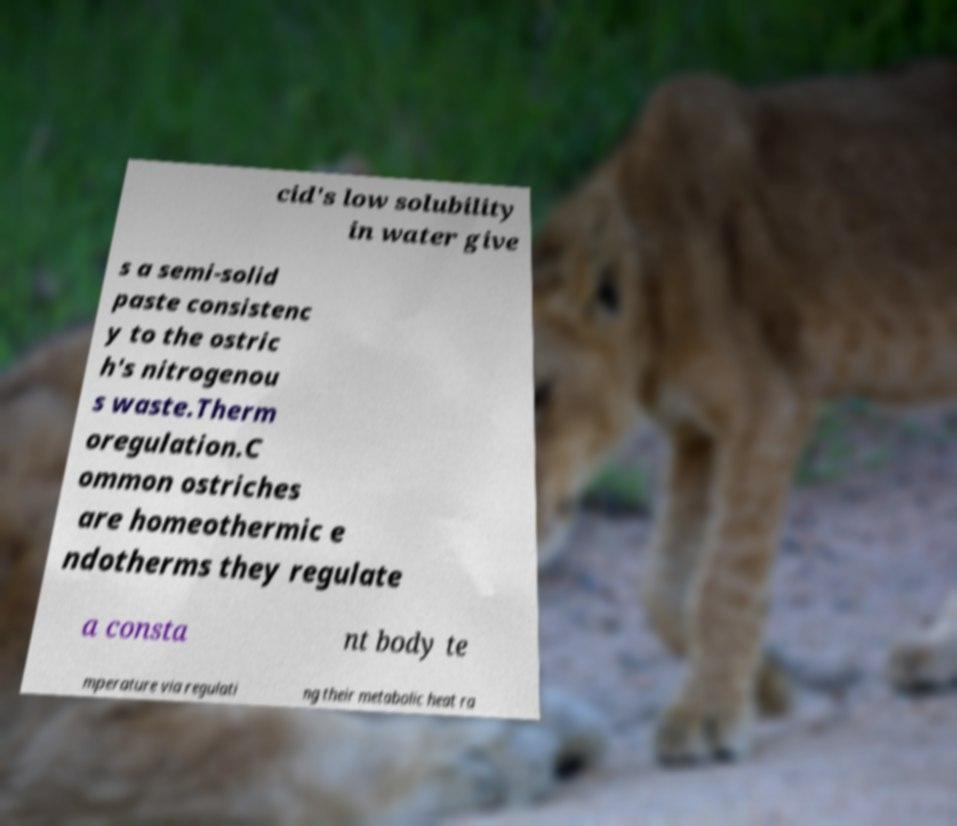There's text embedded in this image that I need extracted. Can you transcribe it verbatim? cid's low solubility in water give s a semi-solid paste consistenc y to the ostric h's nitrogenou s waste.Therm oregulation.C ommon ostriches are homeothermic e ndotherms they regulate a consta nt body te mperature via regulati ng their metabolic heat ra 